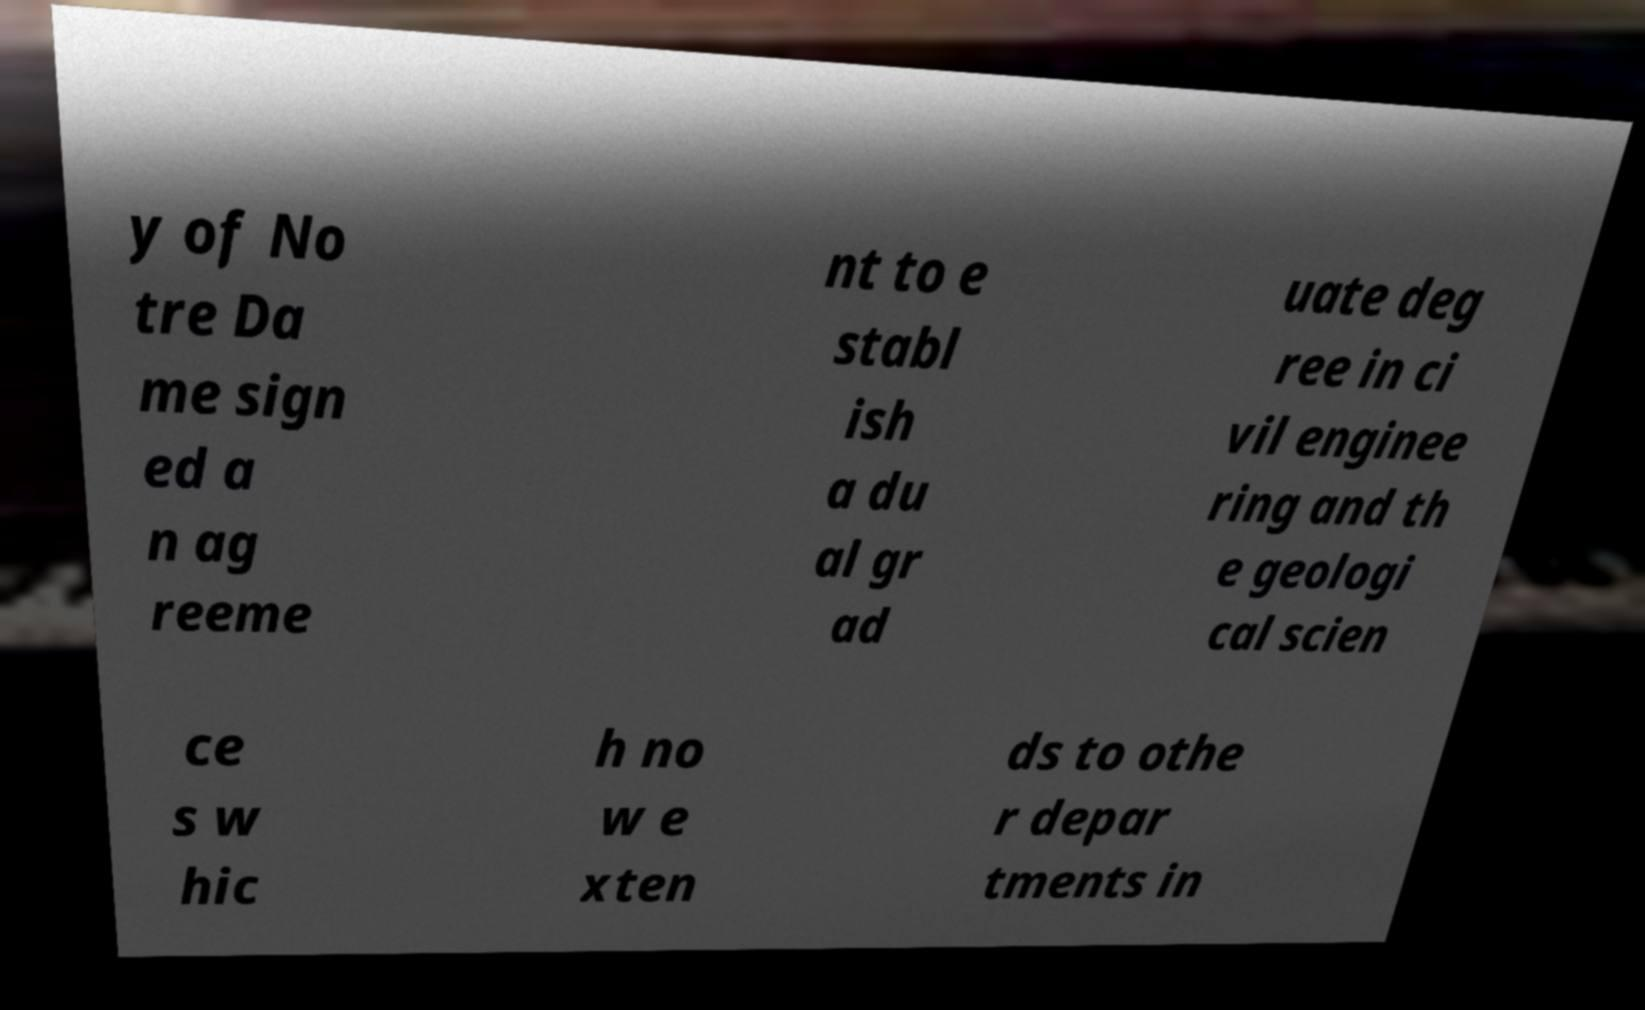Could you assist in decoding the text presented in this image and type it out clearly? y of No tre Da me sign ed a n ag reeme nt to e stabl ish a du al gr ad uate deg ree in ci vil enginee ring and th e geologi cal scien ce s w hic h no w e xten ds to othe r depar tments in 